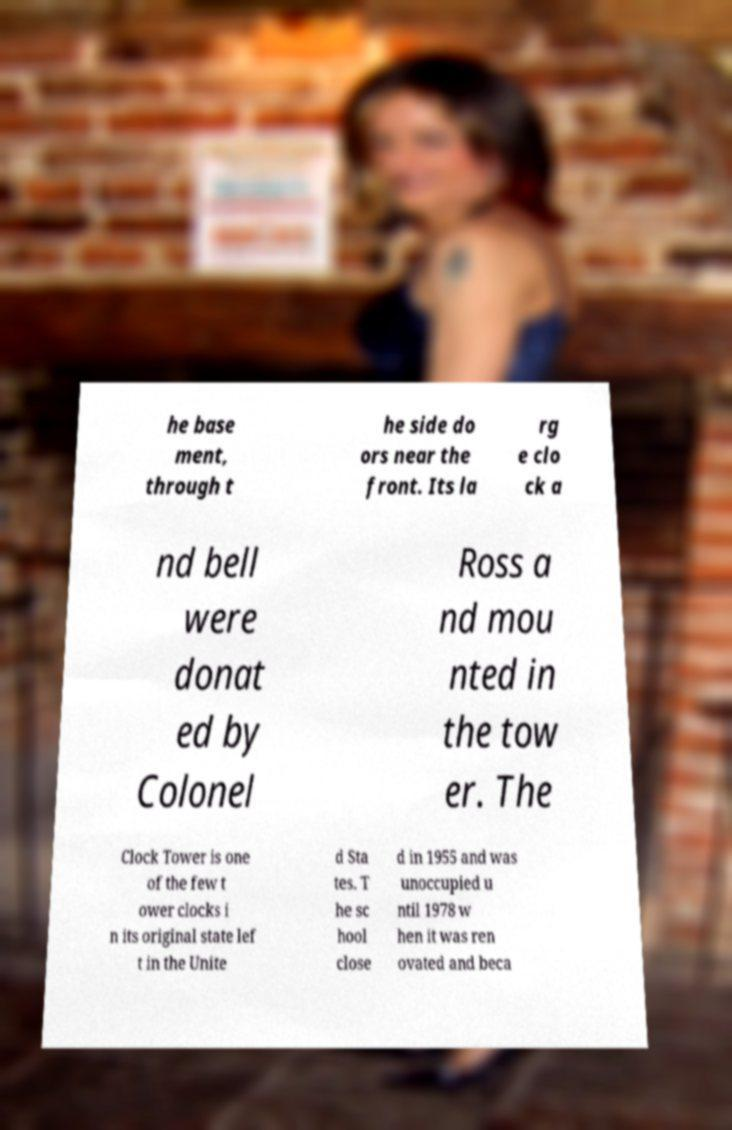Could you assist in decoding the text presented in this image and type it out clearly? he base ment, through t he side do ors near the front. Its la rg e clo ck a nd bell were donat ed by Colonel Ross a nd mou nted in the tow er. The Clock Tower is one of the few t ower clocks i n its original state lef t in the Unite d Sta tes. T he sc hool close d in 1955 and was unoccupied u ntil 1978 w hen it was ren ovated and beca 